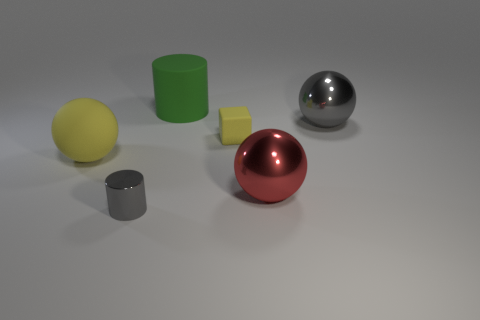Add 3 small yellow rubber balls. How many objects exist? 9 Subtract all blocks. How many objects are left? 5 Subtract 0 cyan balls. How many objects are left? 6 Subtract all large spheres. Subtract all tiny blue rubber blocks. How many objects are left? 3 Add 5 small yellow cubes. How many small yellow cubes are left? 6 Add 2 red rubber blocks. How many red rubber blocks exist? 2 